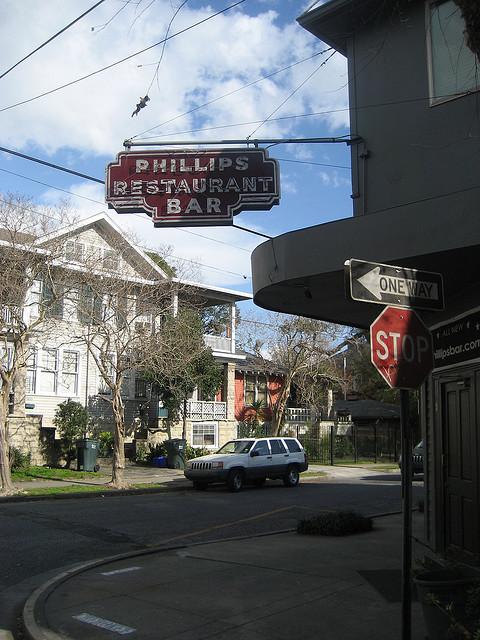Can you buy any magazines in this store?
Keep it brief. No. What is the name on the top line of the sign?
Short answer required. Phillips. What street signs are visible?
Write a very short answer. One way. Which way is the one way sign pointing?
Keep it brief. Left. 